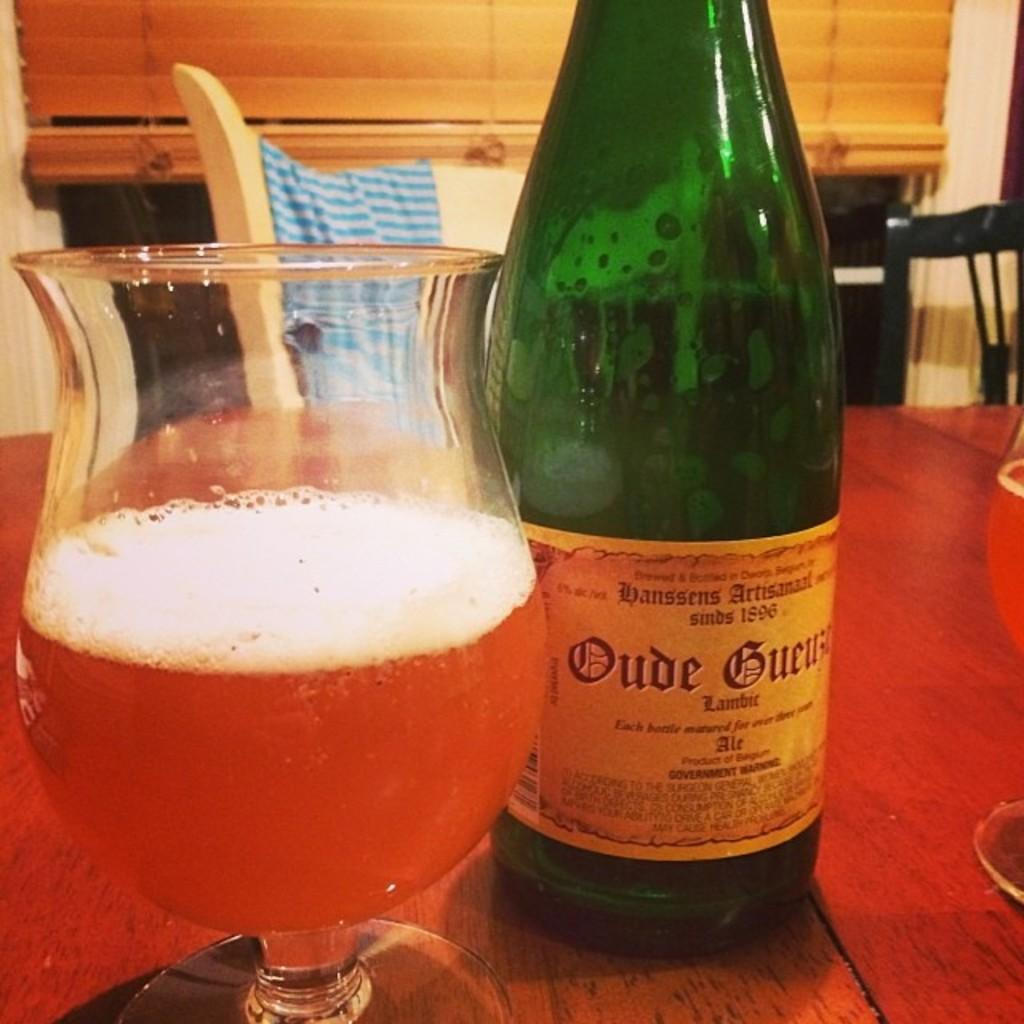What is placed on the table in the image? There is a glass and a bottle on the table in the image. What else can be seen near the table? There is a chair with cloth beside the table. What type of achievement is the beggar celebrating in the image? There is no beggar present in the image, and therefore no achievement to celebrate. 